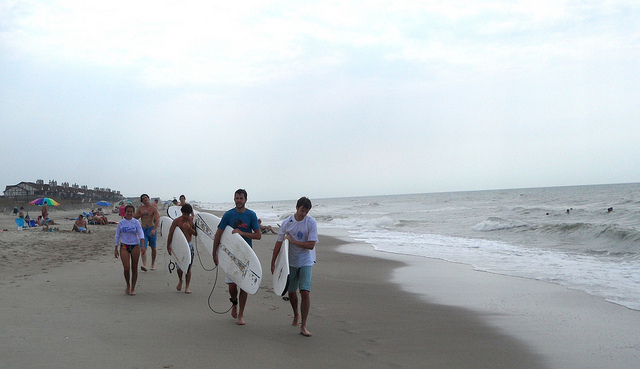What kind of activities do the people in the image seem to be doing? The image depicts a group of people walking on the beach, with a couple of them carrying surfboards, suggesting they might be surfers heading towards or returning from the waves for some surfing activity. 